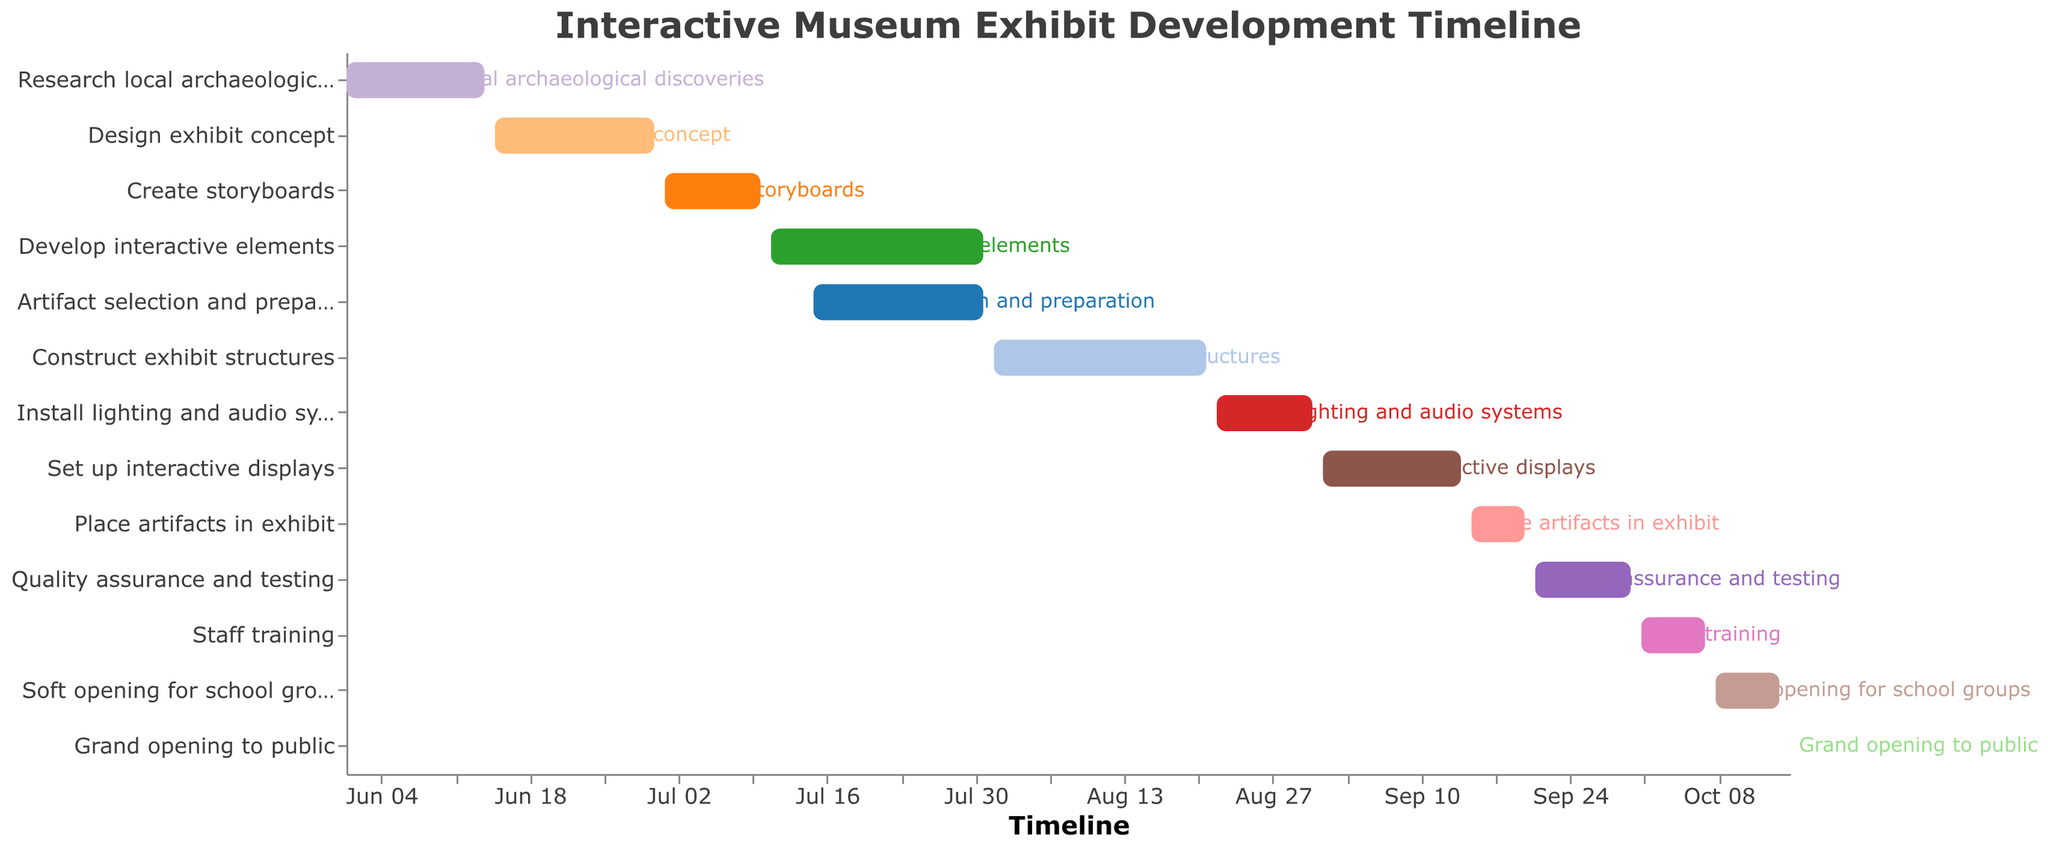What is the duration of the task "Develop interactive elements"? The task "Develop interactive elements" starts on July 11 and ends on July 31, so the duration is 21 days.
Answer: 21 days How many tasks are scheduled to end in July? The tasks "Create storyboards," "Develop interactive elements," and "Artifact selection and preparation" all end in July, which makes it three tasks.
Answer: 3 tasks Which task has the shortest duration and what is its duration? The "Grand opening to public" task has the shortest duration, lasting only 1 day.
Answer: 1 day What is the total duration of all tasks ending in September? The tasks ending in September are "Set up interactive displays" (14 days), "Place artifacts in exhibit" (6 days), and "Quality assurance and testing" (10 days). The total duration is 14 + 6 + 10 = 30 days.
Answer: 30 days Which task starts immediately after "Construct exhibit structures" ends? "Install lighting and audio systems" starts on August 22, the day after "Construct exhibit structures" ends on August 21.
Answer: Install lighting and audio systems Compare the durations of "Staff training" and "Soft opening for school groups." Which one is longer? "Staff training" lasts 7 days, and "Soft opening for school groups" also lasts 7 days. Therefore, their durations are equal.
Answer: Equal durations How many tasks involve setting up or installing components? The tasks involving setup or installation are "Install lighting and audio systems" and "Set up interactive displays," totaling 2 tasks.
Answer: 2 tasks What is the total duration from the start of the first task to the grand opening to the public? The first task starts on June 1, and the grand opening is on October 15. The total duration is from June 1 to October 15, which is about 137 days.
Answer: 137 days Which task overlaps in time with "Artifact selection and preparation"? "Develop interactive elements" (July 11 - July 31) and "Artifact selection and preparation" (July 15 - July 31) overlap in their durations.
Answer: Develop interactive elements 